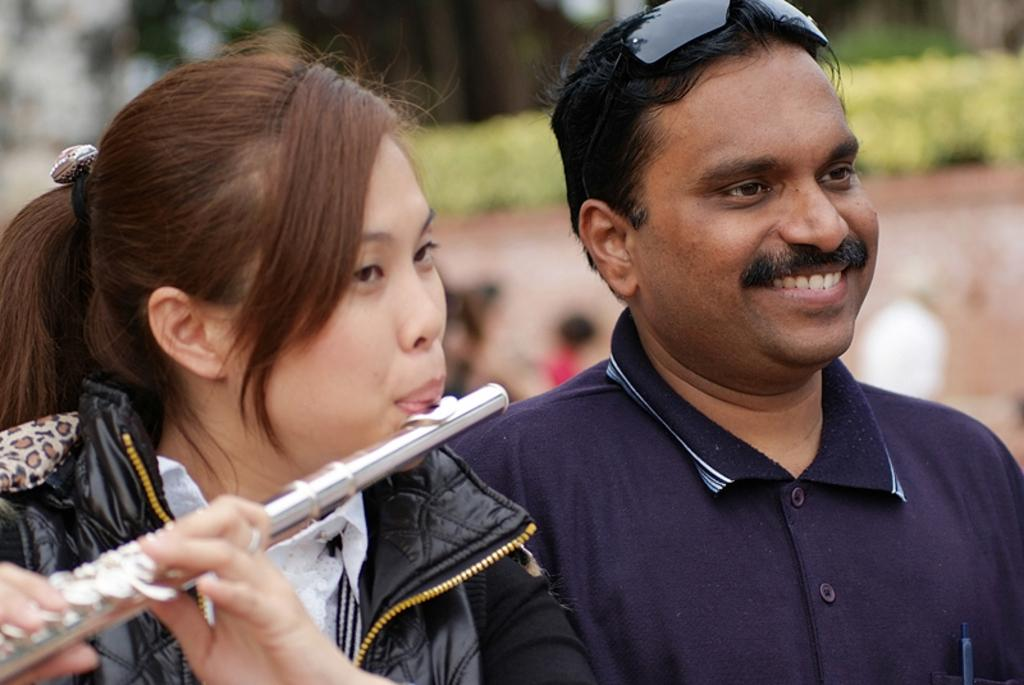How many people are in the image? There are two persons in the image. Can you describe one of the persons? One of the persons is a woman. What is the woman wearing? The woman is wearing a black jacket. What is the woman doing in the image? The woman is playing a music instrument. What type of tree can be seen in the background of the image? There is no tree visible in the background of the image. What authority figure is present in the image? There is no authority figure present in the image. 